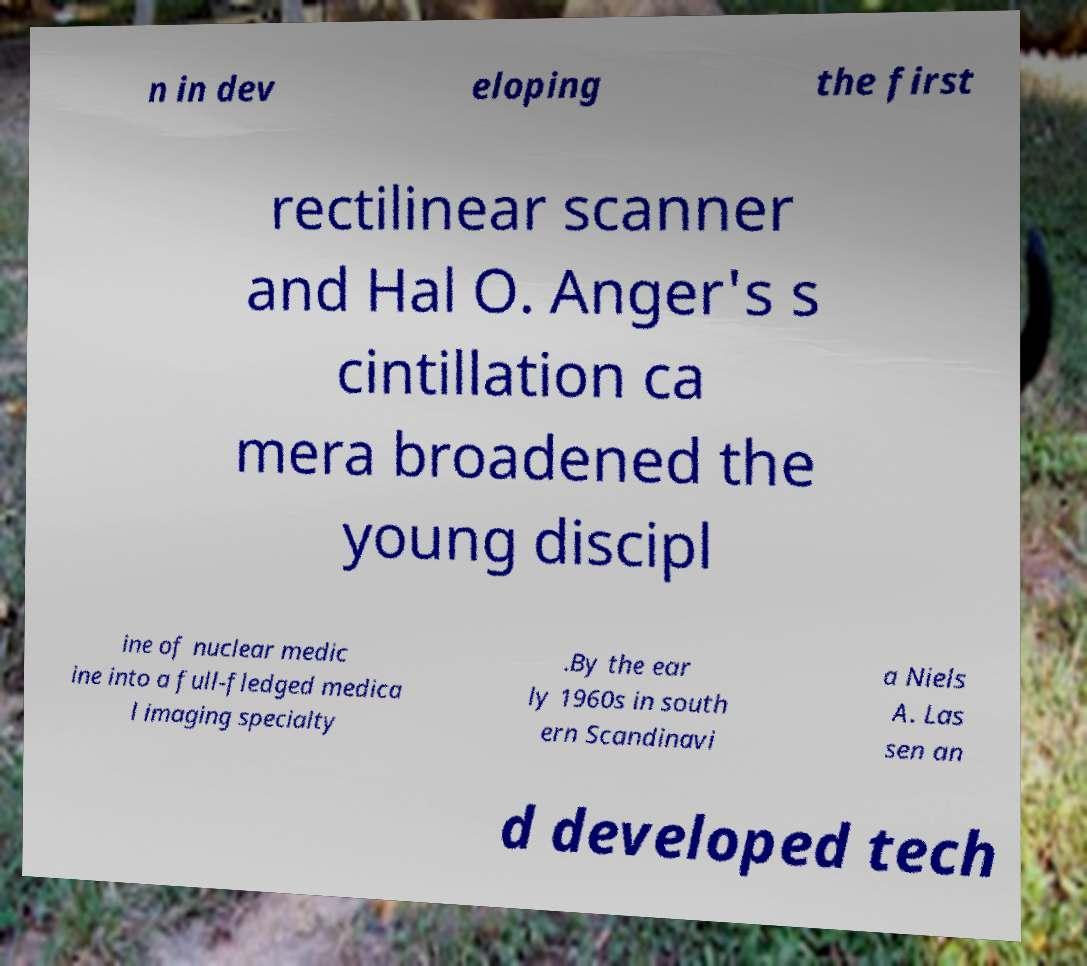Could you assist in decoding the text presented in this image and type it out clearly? n in dev eloping the first rectilinear scanner and Hal O. Anger's s cintillation ca mera broadened the young discipl ine of nuclear medic ine into a full-fledged medica l imaging specialty .By the ear ly 1960s in south ern Scandinavi a Niels A. Las sen an d developed tech 